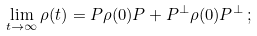<formula> <loc_0><loc_0><loc_500><loc_500>\lim _ { t \to \infty } \rho ( t ) = P \rho ( 0 ) P + P ^ { \bot } \rho ( 0 ) P ^ { \bot } \, ;</formula> 